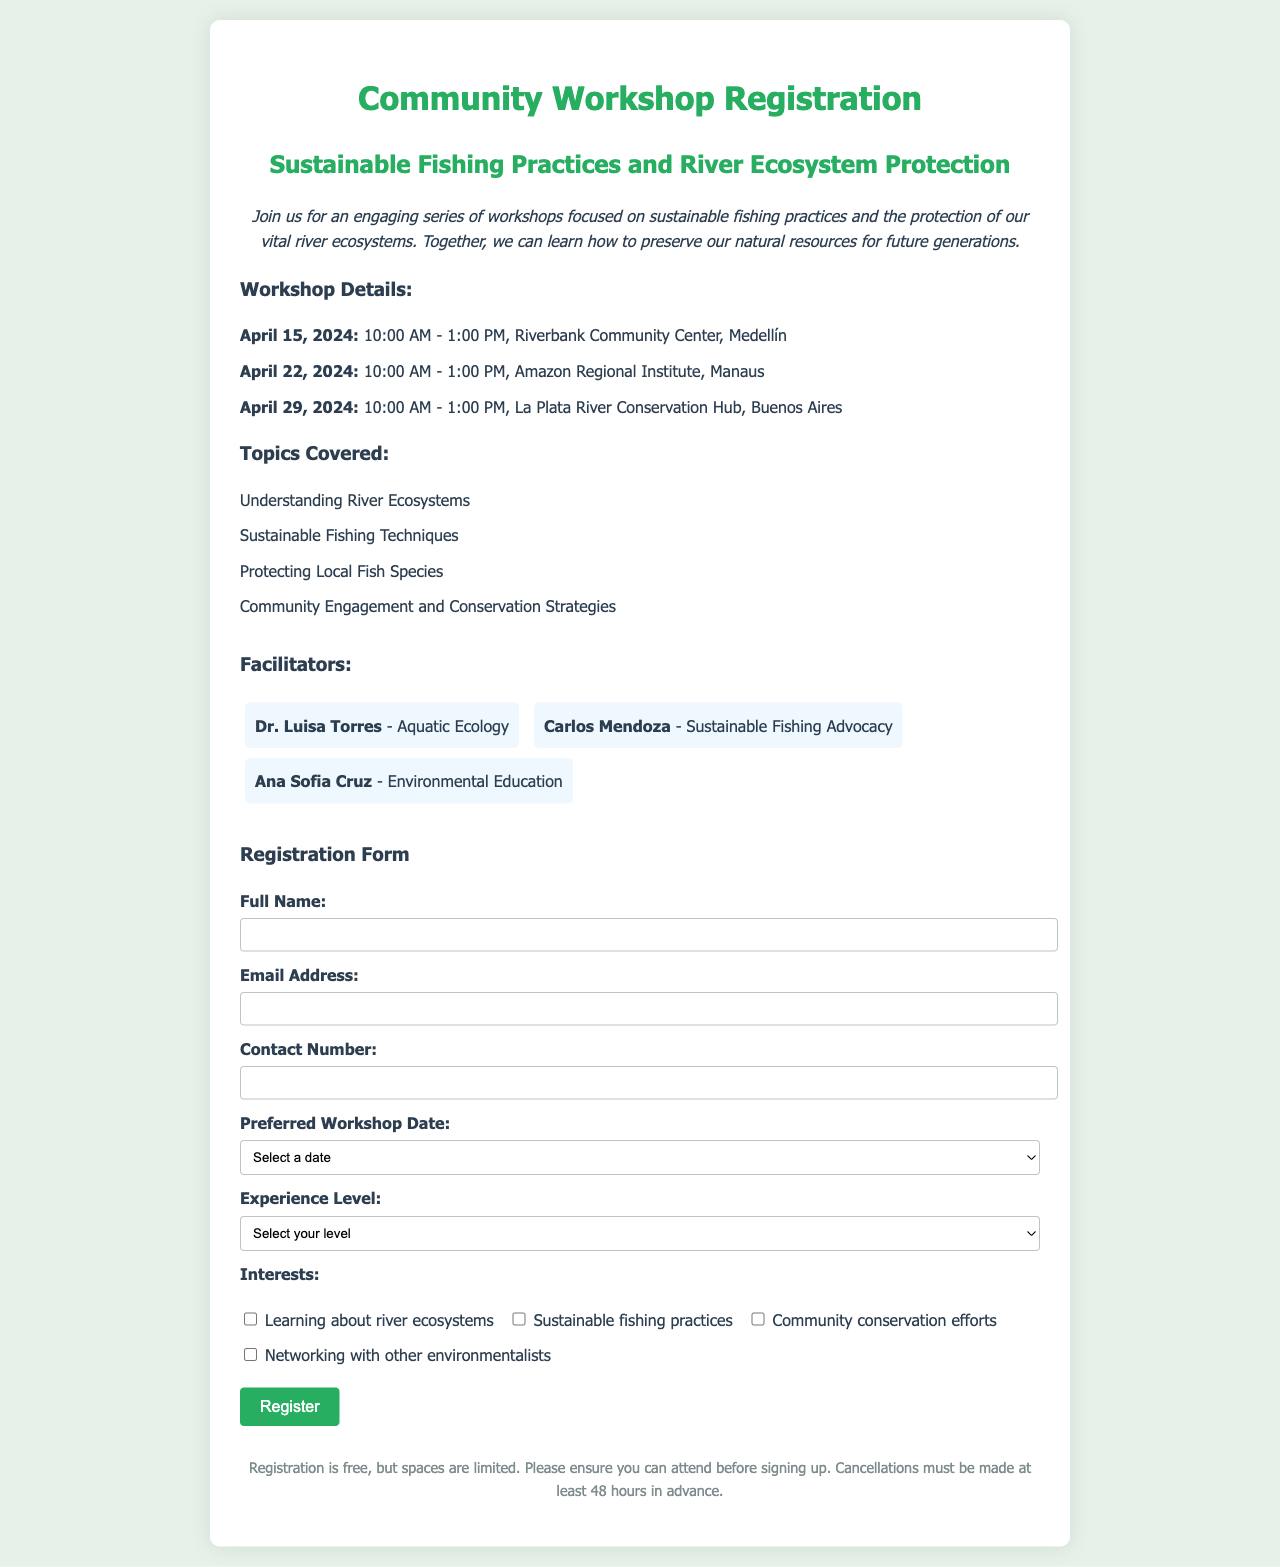What is the title of the workshop? The title of the workshop is clearly stated at the top of the document.
Answer: Community Workshop Registration What are the workshop dates? The document lists specific dates for each workshop session.
Answer: April 15, April 22, April 29 Where is the Medellín workshop being held? The location for the Medellín workshop is mentioned in the details section.
Answer: Riverbank Community Center Who is facilitating the workshops? The document provides the names and specialties of the workshop facilitators.
Answer: Dr. Luisa Torres, Carlos Mendoza, Ana Sofia Cruz What experience levels can participants select? The registration form includes options for different levels of experience.
Answer: Beginner, Intermediate, Advanced Which topic focuses on local fish species? The workshop details list the specific topics covered during the sessions.
Answer: Protecting Local Fish Species How many hours do the workshops run? The document specifies the duration of each workshop session.
Answer: 3 hours Is there a cancellation policy mentioned? The document includes a section on registration conditions and cancellations.
Answer: Yes, 48 hours in advance What is the purpose of these workshops? The introductory text explains the overall goal of the workshops.
Answer: Learn about sustainable fishing practices and river ecosystem protection 